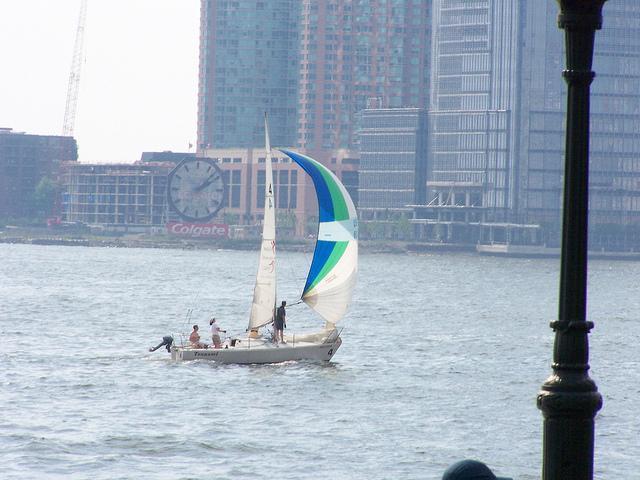What period of the day is shown here?
Indicate the correct response by choosing from the four available options to answer the question.
Options: Morning, afternoon, evening, night. Afternoon. 